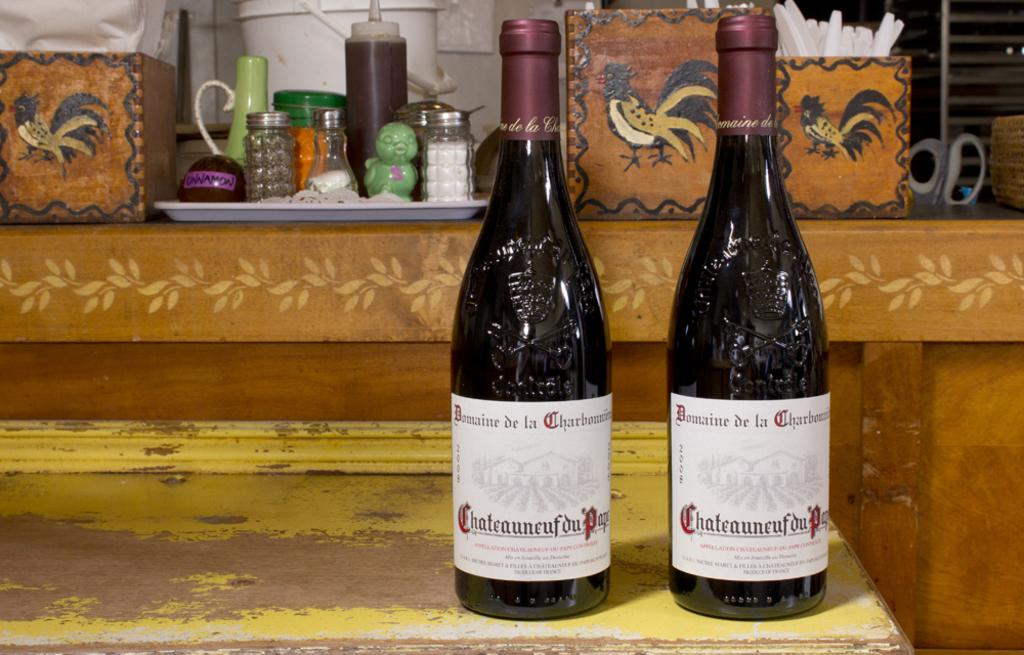Provide a one-sentence caption for the provided image. Two bottles of Chateauneuf du Papi wine are sitting on a counter. 